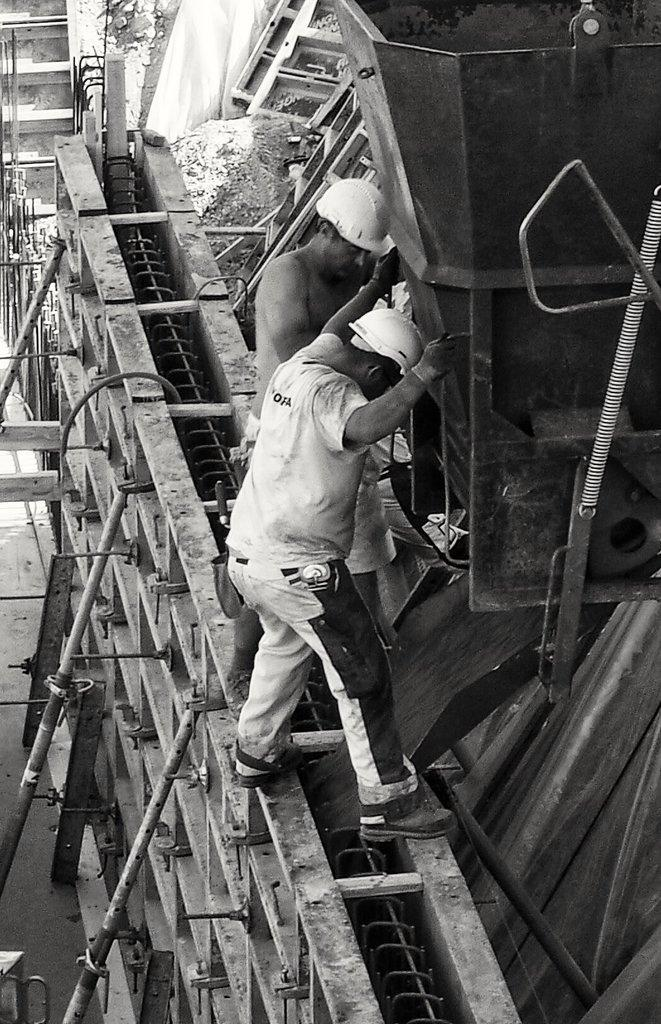What type of picture is in the image? The image contains a black and white picture. How many people are in the picture? There are two persons in the picture. What are the persons wearing on their heads? The persons are wearing helmets. What material can be seen in the picture? There are metal rods in the picture. What type of equipment is present in the picture? There are machines in the picture. What flavor of bean is being used in the picture? There is no bean present in the image, so it is not possible to determine the flavor. 